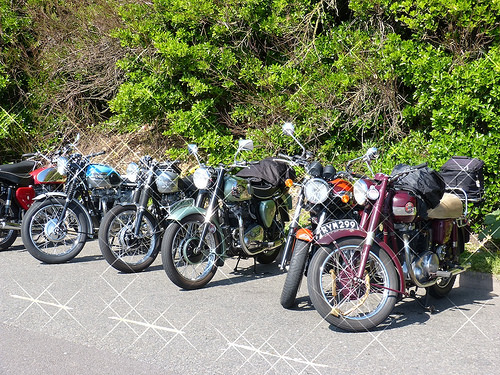<image>
Can you confirm if the wheel is on the pavement? Yes. Looking at the image, I can see the wheel is positioned on top of the pavement, with the pavement providing support. Is the lock on the motorcycle? No. The lock is not positioned on the motorcycle. They may be near each other, but the lock is not supported by or resting on top of the motorcycle. Is the motorcycle to the left of the motorcycle? Yes. From this viewpoint, the motorcycle is positioned to the left side relative to the motorcycle. 